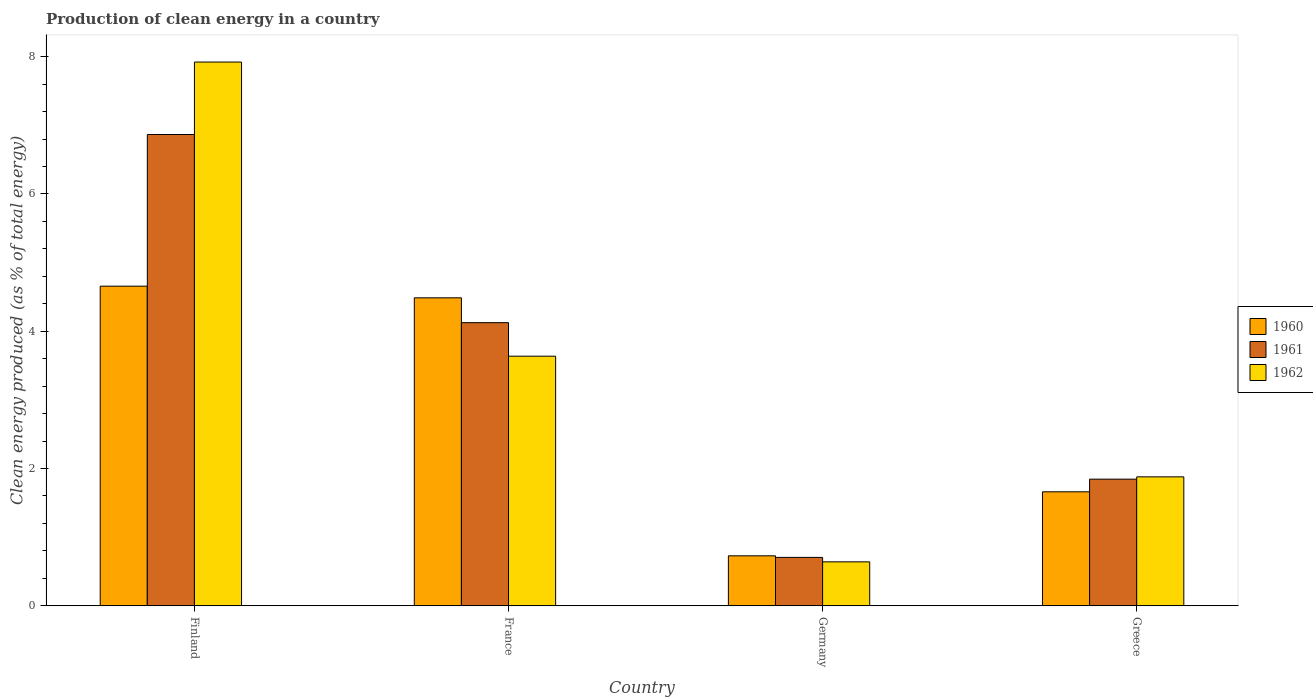How many different coloured bars are there?
Your answer should be compact. 3. How many groups of bars are there?
Your answer should be compact. 4. Are the number of bars per tick equal to the number of legend labels?
Offer a very short reply. Yes. Are the number of bars on each tick of the X-axis equal?
Keep it short and to the point. Yes. What is the label of the 2nd group of bars from the left?
Offer a terse response. France. In how many cases, is the number of bars for a given country not equal to the number of legend labels?
Your answer should be very brief. 0. What is the percentage of clean energy produced in 1962 in Greece?
Give a very brief answer. 1.88. Across all countries, what is the maximum percentage of clean energy produced in 1962?
Give a very brief answer. 7.92. Across all countries, what is the minimum percentage of clean energy produced in 1960?
Give a very brief answer. 0.73. In which country was the percentage of clean energy produced in 1962 maximum?
Offer a very short reply. Finland. In which country was the percentage of clean energy produced in 1961 minimum?
Give a very brief answer. Germany. What is the total percentage of clean energy produced in 1960 in the graph?
Make the answer very short. 11.53. What is the difference between the percentage of clean energy produced in 1961 in Finland and that in Greece?
Offer a terse response. 5.02. What is the difference between the percentage of clean energy produced in 1961 in Greece and the percentage of clean energy produced in 1962 in Finland?
Provide a succinct answer. -6.08. What is the average percentage of clean energy produced in 1960 per country?
Make the answer very short. 2.88. What is the difference between the percentage of clean energy produced of/in 1960 and percentage of clean energy produced of/in 1962 in Germany?
Offer a terse response. 0.09. What is the ratio of the percentage of clean energy produced in 1961 in France to that in Greece?
Your answer should be very brief. 2.24. Is the percentage of clean energy produced in 1961 in Finland less than that in France?
Make the answer very short. No. Is the difference between the percentage of clean energy produced in 1960 in France and Greece greater than the difference between the percentage of clean energy produced in 1962 in France and Greece?
Provide a short and direct response. Yes. What is the difference between the highest and the second highest percentage of clean energy produced in 1960?
Offer a very short reply. -3. What is the difference between the highest and the lowest percentage of clean energy produced in 1962?
Keep it short and to the point. 7.28. In how many countries, is the percentage of clean energy produced in 1962 greater than the average percentage of clean energy produced in 1962 taken over all countries?
Offer a terse response. 2. Is the sum of the percentage of clean energy produced in 1962 in France and Greece greater than the maximum percentage of clean energy produced in 1960 across all countries?
Your answer should be compact. Yes. What does the 2nd bar from the left in Finland represents?
Offer a terse response. 1961. Is it the case that in every country, the sum of the percentage of clean energy produced in 1960 and percentage of clean energy produced in 1961 is greater than the percentage of clean energy produced in 1962?
Your answer should be compact. Yes. How many bars are there?
Make the answer very short. 12. Are all the bars in the graph horizontal?
Make the answer very short. No. What is the difference between two consecutive major ticks on the Y-axis?
Provide a succinct answer. 2. Are the values on the major ticks of Y-axis written in scientific E-notation?
Your answer should be very brief. No. Does the graph contain grids?
Your answer should be very brief. No. Where does the legend appear in the graph?
Your answer should be very brief. Center right. How many legend labels are there?
Give a very brief answer. 3. What is the title of the graph?
Provide a succinct answer. Production of clean energy in a country. What is the label or title of the Y-axis?
Make the answer very short. Clean energy produced (as % of total energy). What is the Clean energy produced (as % of total energy) in 1960 in Finland?
Give a very brief answer. 4.66. What is the Clean energy produced (as % of total energy) of 1961 in Finland?
Give a very brief answer. 6.87. What is the Clean energy produced (as % of total energy) in 1962 in Finland?
Your response must be concise. 7.92. What is the Clean energy produced (as % of total energy) of 1960 in France?
Your answer should be compact. 4.49. What is the Clean energy produced (as % of total energy) in 1961 in France?
Make the answer very short. 4.12. What is the Clean energy produced (as % of total energy) of 1962 in France?
Give a very brief answer. 3.64. What is the Clean energy produced (as % of total energy) of 1960 in Germany?
Your answer should be compact. 0.73. What is the Clean energy produced (as % of total energy) of 1961 in Germany?
Offer a terse response. 0.7. What is the Clean energy produced (as % of total energy) in 1962 in Germany?
Your response must be concise. 0.64. What is the Clean energy produced (as % of total energy) of 1960 in Greece?
Keep it short and to the point. 1.66. What is the Clean energy produced (as % of total energy) in 1961 in Greece?
Keep it short and to the point. 1.84. What is the Clean energy produced (as % of total energy) in 1962 in Greece?
Your answer should be compact. 1.88. Across all countries, what is the maximum Clean energy produced (as % of total energy) in 1960?
Keep it short and to the point. 4.66. Across all countries, what is the maximum Clean energy produced (as % of total energy) in 1961?
Your answer should be compact. 6.87. Across all countries, what is the maximum Clean energy produced (as % of total energy) of 1962?
Offer a terse response. 7.92. Across all countries, what is the minimum Clean energy produced (as % of total energy) of 1960?
Keep it short and to the point. 0.73. Across all countries, what is the minimum Clean energy produced (as % of total energy) of 1961?
Ensure brevity in your answer.  0.7. Across all countries, what is the minimum Clean energy produced (as % of total energy) in 1962?
Your response must be concise. 0.64. What is the total Clean energy produced (as % of total energy) in 1960 in the graph?
Your answer should be very brief. 11.53. What is the total Clean energy produced (as % of total energy) in 1961 in the graph?
Offer a terse response. 13.54. What is the total Clean energy produced (as % of total energy) in 1962 in the graph?
Keep it short and to the point. 14.08. What is the difference between the Clean energy produced (as % of total energy) in 1960 in Finland and that in France?
Your answer should be very brief. 0.17. What is the difference between the Clean energy produced (as % of total energy) of 1961 in Finland and that in France?
Offer a very short reply. 2.74. What is the difference between the Clean energy produced (as % of total energy) in 1962 in Finland and that in France?
Ensure brevity in your answer.  4.28. What is the difference between the Clean energy produced (as % of total energy) in 1960 in Finland and that in Germany?
Ensure brevity in your answer.  3.93. What is the difference between the Clean energy produced (as % of total energy) of 1961 in Finland and that in Germany?
Your answer should be compact. 6.16. What is the difference between the Clean energy produced (as % of total energy) in 1962 in Finland and that in Germany?
Make the answer very short. 7.28. What is the difference between the Clean energy produced (as % of total energy) of 1960 in Finland and that in Greece?
Keep it short and to the point. 3. What is the difference between the Clean energy produced (as % of total energy) of 1961 in Finland and that in Greece?
Provide a short and direct response. 5.02. What is the difference between the Clean energy produced (as % of total energy) of 1962 in Finland and that in Greece?
Your answer should be very brief. 6.04. What is the difference between the Clean energy produced (as % of total energy) in 1960 in France and that in Germany?
Your answer should be very brief. 3.76. What is the difference between the Clean energy produced (as % of total energy) of 1961 in France and that in Germany?
Give a very brief answer. 3.42. What is the difference between the Clean energy produced (as % of total energy) of 1962 in France and that in Germany?
Your response must be concise. 3. What is the difference between the Clean energy produced (as % of total energy) of 1960 in France and that in Greece?
Provide a succinct answer. 2.83. What is the difference between the Clean energy produced (as % of total energy) in 1961 in France and that in Greece?
Your answer should be compact. 2.28. What is the difference between the Clean energy produced (as % of total energy) in 1962 in France and that in Greece?
Keep it short and to the point. 1.76. What is the difference between the Clean energy produced (as % of total energy) of 1960 in Germany and that in Greece?
Offer a terse response. -0.93. What is the difference between the Clean energy produced (as % of total energy) of 1961 in Germany and that in Greece?
Make the answer very short. -1.14. What is the difference between the Clean energy produced (as % of total energy) of 1962 in Germany and that in Greece?
Offer a very short reply. -1.24. What is the difference between the Clean energy produced (as % of total energy) in 1960 in Finland and the Clean energy produced (as % of total energy) in 1961 in France?
Provide a short and direct response. 0.53. What is the difference between the Clean energy produced (as % of total energy) in 1960 in Finland and the Clean energy produced (as % of total energy) in 1962 in France?
Offer a very short reply. 1.02. What is the difference between the Clean energy produced (as % of total energy) of 1961 in Finland and the Clean energy produced (as % of total energy) of 1962 in France?
Provide a succinct answer. 3.23. What is the difference between the Clean energy produced (as % of total energy) of 1960 in Finland and the Clean energy produced (as % of total energy) of 1961 in Germany?
Provide a succinct answer. 3.95. What is the difference between the Clean energy produced (as % of total energy) in 1960 in Finland and the Clean energy produced (as % of total energy) in 1962 in Germany?
Keep it short and to the point. 4.02. What is the difference between the Clean energy produced (as % of total energy) in 1961 in Finland and the Clean energy produced (as % of total energy) in 1962 in Germany?
Your response must be concise. 6.23. What is the difference between the Clean energy produced (as % of total energy) in 1960 in Finland and the Clean energy produced (as % of total energy) in 1961 in Greece?
Keep it short and to the point. 2.81. What is the difference between the Clean energy produced (as % of total energy) in 1960 in Finland and the Clean energy produced (as % of total energy) in 1962 in Greece?
Provide a short and direct response. 2.78. What is the difference between the Clean energy produced (as % of total energy) in 1961 in Finland and the Clean energy produced (as % of total energy) in 1962 in Greece?
Your answer should be very brief. 4.99. What is the difference between the Clean energy produced (as % of total energy) of 1960 in France and the Clean energy produced (as % of total energy) of 1961 in Germany?
Your answer should be compact. 3.78. What is the difference between the Clean energy produced (as % of total energy) of 1960 in France and the Clean energy produced (as % of total energy) of 1962 in Germany?
Your answer should be compact. 3.85. What is the difference between the Clean energy produced (as % of total energy) of 1961 in France and the Clean energy produced (as % of total energy) of 1962 in Germany?
Make the answer very short. 3.48. What is the difference between the Clean energy produced (as % of total energy) in 1960 in France and the Clean energy produced (as % of total energy) in 1961 in Greece?
Your response must be concise. 2.64. What is the difference between the Clean energy produced (as % of total energy) of 1960 in France and the Clean energy produced (as % of total energy) of 1962 in Greece?
Your answer should be very brief. 2.61. What is the difference between the Clean energy produced (as % of total energy) of 1961 in France and the Clean energy produced (as % of total energy) of 1962 in Greece?
Ensure brevity in your answer.  2.25. What is the difference between the Clean energy produced (as % of total energy) in 1960 in Germany and the Clean energy produced (as % of total energy) in 1961 in Greece?
Provide a succinct answer. -1.12. What is the difference between the Clean energy produced (as % of total energy) in 1960 in Germany and the Clean energy produced (as % of total energy) in 1962 in Greece?
Ensure brevity in your answer.  -1.15. What is the difference between the Clean energy produced (as % of total energy) in 1961 in Germany and the Clean energy produced (as % of total energy) in 1962 in Greece?
Offer a terse response. -1.17. What is the average Clean energy produced (as % of total energy) of 1960 per country?
Offer a very short reply. 2.88. What is the average Clean energy produced (as % of total energy) of 1961 per country?
Provide a succinct answer. 3.38. What is the average Clean energy produced (as % of total energy) of 1962 per country?
Provide a short and direct response. 3.52. What is the difference between the Clean energy produced (as % of total energy) in 1960 and Clean energy produced (as % of total energy) in 1961 in Finland?
Give a very brief answer. -2.21. What is the difference between the Clean energy produced (as % of total energy) of 1960 and Clean energy produced (as % of total energy) of 1962 in Finland?
Keep it short and to the point. -3.26. What is the difference between the Clean energy produced (as % of total energy) in 1961 and Clean energy produced (as % of total energy) in 1962 in Finland?
Provide a succinct answer. -1.06. What is the difference between the Clean energy produced (as % of total energy) of 1960 and Clean energy produced (as % of total energy) of 1961 in France?
Provide a short and direct response. 0.36. What is the difference between the Clean energy produced (as % of total energy) in 1960 and Clean energy produced (as % of total energy) in 1962 in France?
Offer a very short reply. 0.85. What is the difference between the Clean energy produced (as % of total energy) in 1961 and Clean energy produced (as % of total energy) in 1962 in France?
Keep it short and to the point. 0.49. What is the difference between the Clean energy produced (as % of total energy) in 1960 and Clean energy produced (as % of total energy) in 1961 in Germany?
Give a very brief answer. 0.02. What is the difference between the Clean energy produced (as % of total energy) in 1960 and Clean energy produced (as % of total energy) in 1962 in Germany?
Provide a short and direct response. 0.09. What is the difference between the Clean energy produced (as % of total energy) of 1961 and Clean energy produced (as % of total energy) of 1962 in Germany?
Provide a succinct answer. 0.06. What is the difference between the Clean energy produced (as % of total energy) in 1960 and Clean energy produced (as % of total energy) in 1961 in Greece?
Give a very brief answer. -0.18. What is the difference between the Clean energy produced (as % of total energy) in 1960 and Clean energy produced (as % of total energy) in 1962 in Greece?
Give a very brief answer. -0.22. What is the difference between the Clean energy produced (as % of total energy) of 1961 and Clean energy produced (as % of total energy) of 1962 in Greece?
Offer a terse response. -0.03. What is the ratio of the Clean energy produced (as % of total energy) of 1960 in Finland to that in France?
Your response must be concise. 1.04. What is the ratio of the Clean energy produced (as % of total energy) of 1961 in Finland to that in France?
Offer a very short reply. 1.66. What is the ratio of the Clean energy produced (as % of total energy) in 1962 in Finland to that in France?
Offer a very short reply. 2.18. What is the ratio of the Clean energy produced (as % of total energy) in 1960 in Finland to that in Germany?
Keep it short and to the point. 6.4. What is the ratio of the Clean energy produced (as % of total energy) in 1961 in Finland to that in Germany?
Offer a terse response. 9.74. What is the ratio of the Clean energy produced (as % of total energy) in 1962 in Finland to that in Germany?
Offer a very short reply. 12.37. What is the ratio of the Clean energy produced (as % of total energy) of 1960 in Finland to that in Greece?
Provide a short and direct response. 2.8. What is the ratio of the Clean energy produced (as % of total energy) in 1961 in Finland to that in Greece?
Offer a terse response. 3.72. What is the ratio of the Clean energy produced (as % of total energy) of 1962 in Finland to that in Greece?
Provide a short and direct response. 4.22. What is the ratio of the Clean energy produced (as % of total energy) in 1960 in France to that in Germany?
Offer a terse response. 6.16. What is the ratio of the Clean energy produced (as % of total energy) of 1961 in France to that in Germany?
Make the answer very short. 5.85. What is the ratio of the Clean energy produced (as % of total energy) in 1962 in France to that in Germany?
Your response must be concise. 5.68. What is the ratio of the Clean energy produced (as % of total energy) in 1960 in France to that in Greece?
Your answer should be very brief. 2.7. What is the ratio of the Clean energy produced (as % of total energy) of 1961 in France to that in Greece?
Your answer should be compact. 2.24. What is the ratio of the Clean energy produced (as % of total energy) of 1962 in France to that in Greece?
Make the answer very short. 1.94. What is the ratio of the Clean energy produced (as % of total energy) of 1960 in Germany to that in Greece?
Make the answer very short. 0.44. What is the ratio of the Clean energy produced (as % of total energy) of 1961 in Germany to that in Greece?
Make the answer very short. 0.38. What is the ratio of the Clean energy produced (as % of total energy) in 1962 in Germany to that in Greece?
Your answer should be compact. 0.34. What is the difference between the highest and the second highest Clean energy produced (as % of total energy) in 1960?
Keep it short and to the point. 0.17. What is the difference between the highest and the second highest Clean energy produced (as % of total energy) of 1961?
Offer a very short reply. 2.74. What is the difference between the highest and the second highest Clean energy produced (as % of total energy) of 1962?
Provide a short and direct response. 4.28. What is the difference between the highest and the lowest Clean energy produced (as % of total energy) in 1960?
Provide a succinct answer. 3.93. What is the difference between the highest and the lowest Clean energy produced (as % of total energy) of 1961?
Make the answer very short. 6.16. What is the difference between the highest and the lowest Clean energy produced (as % of total energy) in 1962?
Your answer should be compact. 7.28. 